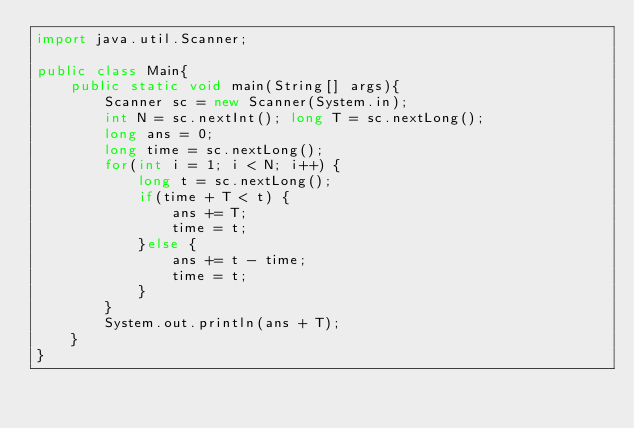Convert code to text. <code><loc_0><loc_0><loc_500><loc_500><_Java_>import java.util.Scanner;

public class Main{
	public static void main(String[] args){
		Scanner sc = new Scanner(System.in);
		int N = sc.nextInt(); long T = sc.nextLong();
		long ans = 0;
		long time = sc.nextLong();
		for(int i = 1; i < N; i++) {
			long t = sc.nextLong();
			if(time + T < t) {
				ans += T;
				time = t;
			}else {
				ans += t - time;
				time = t;
			}
		}
		System.out.println(ans + T);
	}
}</code> 